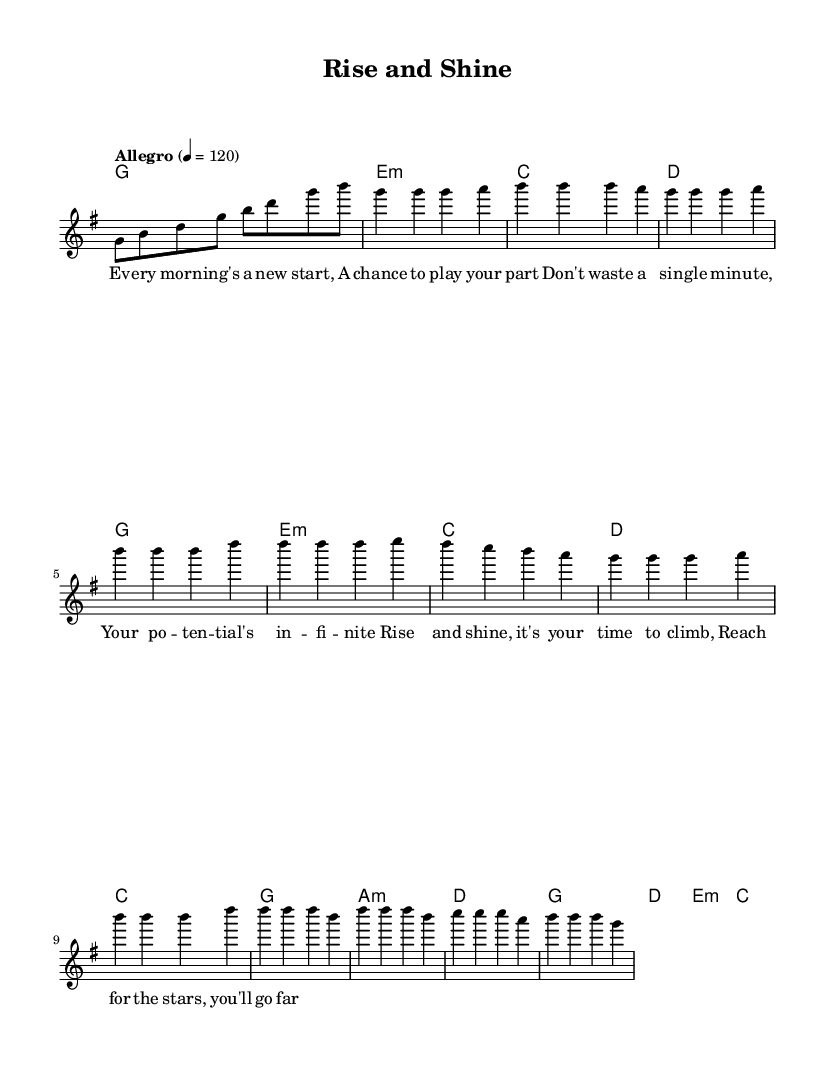What is the key signature of this music? The key signature is G major, which has one sharp (F#). This can be identified at the beginning of the music sheet alongside the treble clef.
Answer: G major What is the time signature of this music? The time signature is 4/4, as indicated at the beginning of the score. This means there are four beats in each measure, and the quarter note gets one beat.
Answer: 4/4 What is the tempo marking of this piece? The tempo marking is "Allegro" set at 120 beats per minute. It appears at the start of the music, providing guidance on the speed of the piece.
Answer: Allegro 120 How many measures are in the verse section? The verse section consists of 4 measures, which can be counted from the melodic notation dedicated to verses in the score.
Answer: 4 measures What instrument is primarily indicated for the lead melody? The lead melody is indicated to be played on a voice, as shown in the score section where it specifies a new Voice labeled "lead".
Answer: Voice What lyrical theme is presented in the chorus? The lyrical theme in the chorus emphasizes motivation and aspiration, specifically encouraging reaching for the stars and personal growth. This can be inferred from the lyrics provided under the chorus section.
Answer: Motivation What chord follows the introduction in the score? The chord following the introduction in the score is E minor, as noted in the harmonic progression after the first measure of the intro.
Answer: E minor 